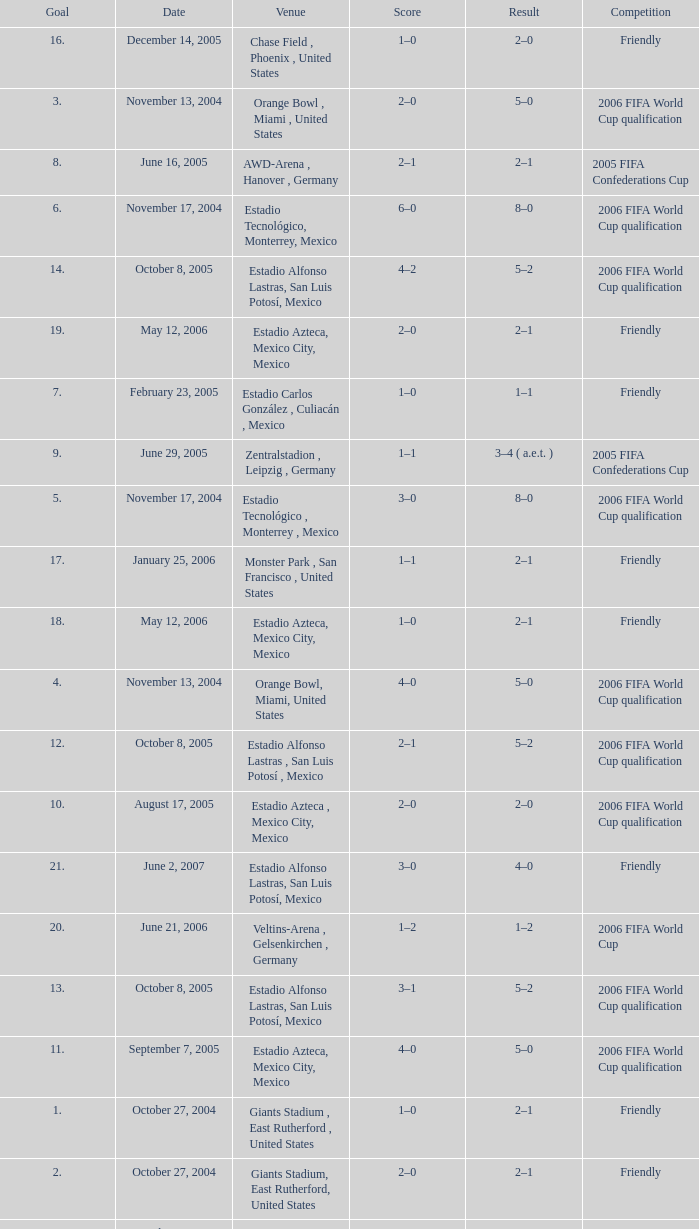Which Score has a Date of october 8, 2005, and a Venue of estadio alfonso lastras, san luis potosí, mexico? 2–1, 3–1, 4–2, 5–2. 